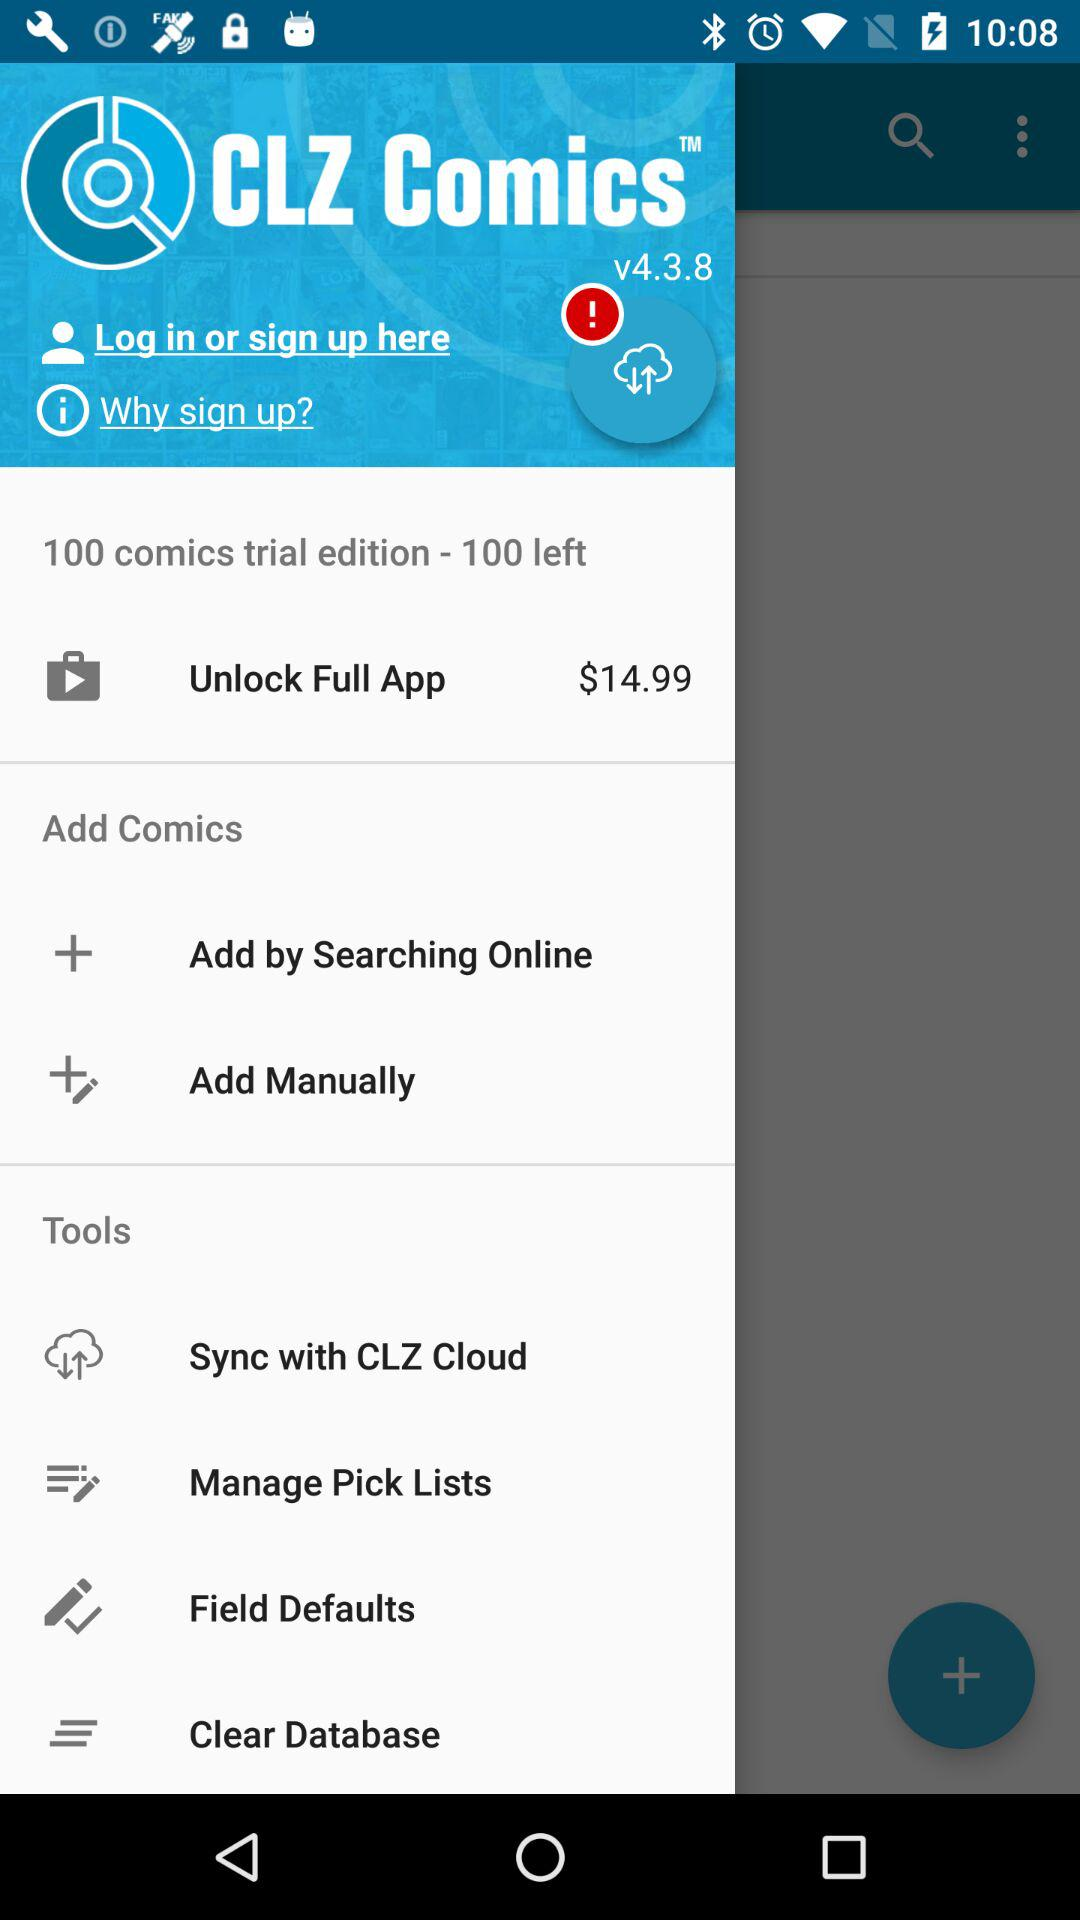What is the copyright date of the "CLZ Comics" application?
When the provided information is insufficient, respond with <no answer>. <no answer> 